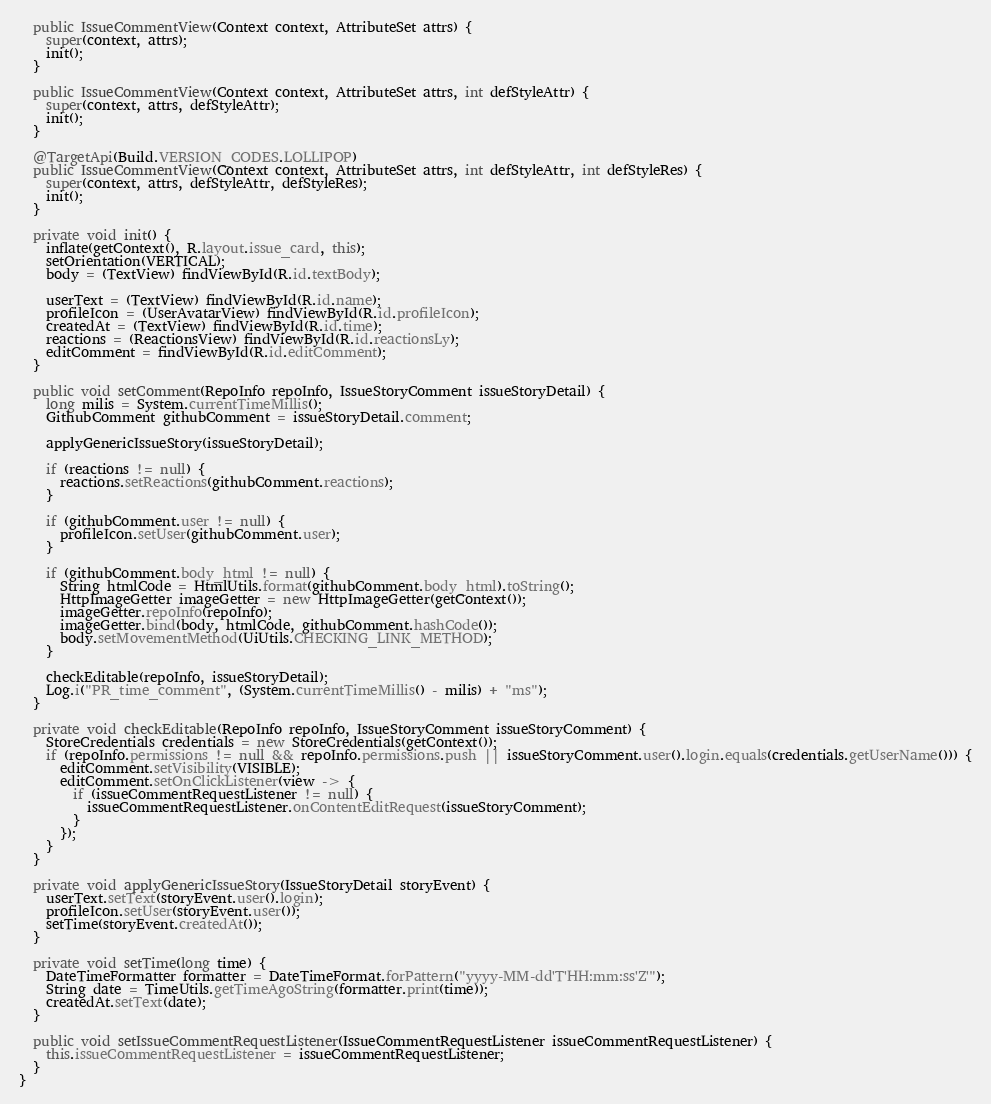Convert code to text. <code><loc_0><loc_0><loc_500><loc_500><_Java_>
  public IssueCommentView(Context context, AttributeSet attrs) {
    super(context, attrs);
    init();
  }

  public IssueCommentView(Context context, AttributeSet attrs, int defStyleAttr) {
    super(context, attrs, defStyleAttr);
    init();
  }

  @TargetApi(Build.VERSION_CODES.LOLLIPOP)
  public IssueCommentView(Context context, AttributeSet attrs, int defStyleAttr, int defStyleRes) {
    super(context, attrs, defStyleAttr, defStyleRes);
    init();
  }

  private void init() {
    inflate(getContext(), R.layout.issue_card, this);
    setOrientation(VERTICAL);
    body = (TextView) findViewById(R.id.textBody);

    userText = (TextView) findViewById(R.id.name);
    profileIcon = (UserAvatarView) findViewById(R.id.profileIcon);
    createdAt = (TextView) findViewById(R.id.time);
    reactions = (ReactionsView) findViewById(R.id.reactionsLy);
    editComment = findViewById(R.id.editComment);
  }

  public void setComment(RepoInfo repoInfo, IssueStoryComment issueStoryDetail) {
    long milis = System.currentTimeMillis();
    GithubComment githubComment = issueStoryDetail.comment;

    applyGenericIssueStory(issueStoryDetail);

    if (reactions != null) {
      reactions.setReactions(githubComment.reactions);
    }

    if (githubComment.user != null) {
      profileIcon.setUser(githubComment.user);
    }

    if (githubComment.body_html != null) {
      String htmlCode = HtmlUtils.format(githubComment.body_html).toString();
      HttpImageGetter imageGetter = new HttpImageGetter(getContext());
      imageGetter.repoInfo(repoInfo);
      imageGetter.bind(body, htmlCode, githubComment.hashCode());
      body.setMovementMethod(UiUtils.CHECKING_LINK_METHOD);
    }

    checkEditable(repoInfo, issueStoryDetail);
    Log.i("PR_time_comment", (System.currentTimeMillis() - milis) + "ms");
  }

  private void checkEditable(RepoInfo repoInfo, IssueStoryComment issueStoryComment) {
    StoreCredentials credentials = new StoreCredentials(getContext());
    if (repoInfo.permissions != null && repoInfo.permissions.push || issueStoryComment.user().login.equals(credentials.getUserName())) {
      editComment.setVisibility(VISIBLE);
      editComment.setOnClickListener(view -> {
        if (issueCommentRequestListener != null) {
          issueCommentRequestListener.onContentEditRequest(issueStoryComment);
        }
      });
    }
  }

  private void applyGenericIssueStory(IssueStoryDetail storyEvent) {
    userText.setText(storyEvent.user().login);
    profileIcon.setUser(storyEvent.user());
    setTime(storyEvent.createdAt());
  }

  private void setTime(long time) {
    DateTimeFormatter formatter = DateTimeFormat.forPattern("yyyy-MM-dd'T'HH:mm:ss'Z'");
    String date = TimeUtils.getTimeAgoString(formatter.print(time));
    createdAt.setText(date);
  }

  public void setIssueCommentRequestListener(IssueCommentRequestListener issueCommentRequestListener) {
    this.issueCommentRequestListener = issueCommentRequestListener;
  }
}
</code> 